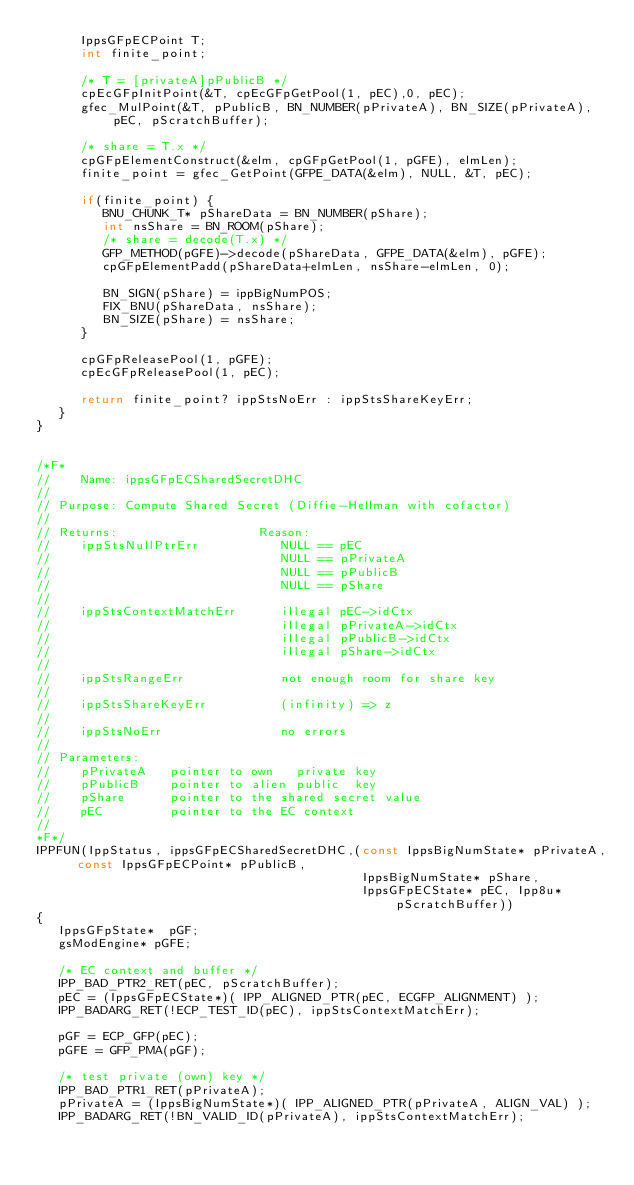Convert code to text. <code><loc_0><loc_0><loc_500><loc_500><_C_>      IppsGFpECPoint T;
      int finite_point;

      /* T = [privateA]pPublicB */
      cpEcGFpInitPoint(&T, cpEcGFpGetPool(1, pEC),0, pEC);
      gfec_MulPoint(&T, pPublicB, BN_NUMBER(pPrivateA), BN_SIZE(pPrivateA), pEC, pScratchBuffer);

      /* share = T.x */
      cpGFpElementConstruct(&elm, cpGFpGetPool(1, pGFE), elmLen);
      finite_point = gfec_GetPoint(GFPE_DATA(&elm), NULL, &T, pEC);

      if(finite_point) {
         BNU_CHUNK_T* pShareData = BN_NUMBER(pShare);
         int nsShare = BN_ROOM(pShare);
         /* share = decode(T.x) */
         GFP_METHOD(pGFE)->decode(pShareData, GFPE_DATA(&elm), pGFE);
         cpGFpElementPadd(pShareData+elmLen, nsShare-elmLen, 0);

         BN_SIGN(pShare) = ippBigNumPOS;
         FIX_BNU(pShareData, nsShare);
         BN_SIZE(pShare) = nsShare;
      }

      cpGFpReleasePool(1, pGFE);
      cpEcGFpReleasePool(1, pEC);

      return finite_point? ippStsNoErr : ippStsShareKeyErr;
   }
}


/*F*
//    Name: ippsGFpECSharedSecretDHC
//
// Purpose: Compute Shared Secret (Diffie-Hellman with cofactor)
//
// Returns:                   Reason:
//    ippStsNullPtrErr           NULL == pEC
//                               NULL == pPrivateA
//                               NULL == pPublicB
//                               NULL == pShare
//
//    ippStsContextMatchErr      illegal pEC->idCtx
//                               illegal pPrivateA->idCtx
//                               illegal pPublicB->idCtx
//                               illegal pShare->idCtx
//
//    ippStsRangeErr             not enough room for share key
//
//    ippStsShareKeyErr          (infinity) => z
//
//    ippStsNoErr                no errors
//
// Parameters:
//    pPrivateA   pointer to own   private key
//    pPublicB    pointer to alien public  key
//    pShare      pointer to the shared secret value
//    pEC         pointer to the EC context
//
*F*/
IPPFUN(IppStatus, ippsGFpECSharedSecretDHC,(const IppsBigNumState* pPrivateA, const IppsGFpECPoint* pPublicB,
                                            IppsBigNumState* pShare,
                                            IppsGFpECState* pEC, Ipp8u* pScratchBuffer))
{
   IppsGFpState*  pGF;
   gsModEngine* pGFE;

   /* EC context and buffer */
   IPP_BAD_PTR2_RET(pEC, pScratchBuffer);
   pEC = (IppsGFpECState*)( IPP_ALIGNED_PTR(pEC, ECGFP_ALIGNMENT) );
   IPP_BADARG_RET(!ECP_TEST_ID(pEC), ippStsContextMatchErr);

   pGF = ECP_GFP(pEC);
   pGFE = GFP_PMA(pGF);

   /* test private (own) key */
   IPP_BAD_PTR1_RET(pPrivateA);
   pPrivateA = (IppsBigNumState*)( IPP_ALIGNED_PTR(pPrivateA, ALIGN_VAL) );
   IPP_BADARG_RET(!BN_VALID_ID(pPrivateA), ippStsContextMatchErr);
</code> 